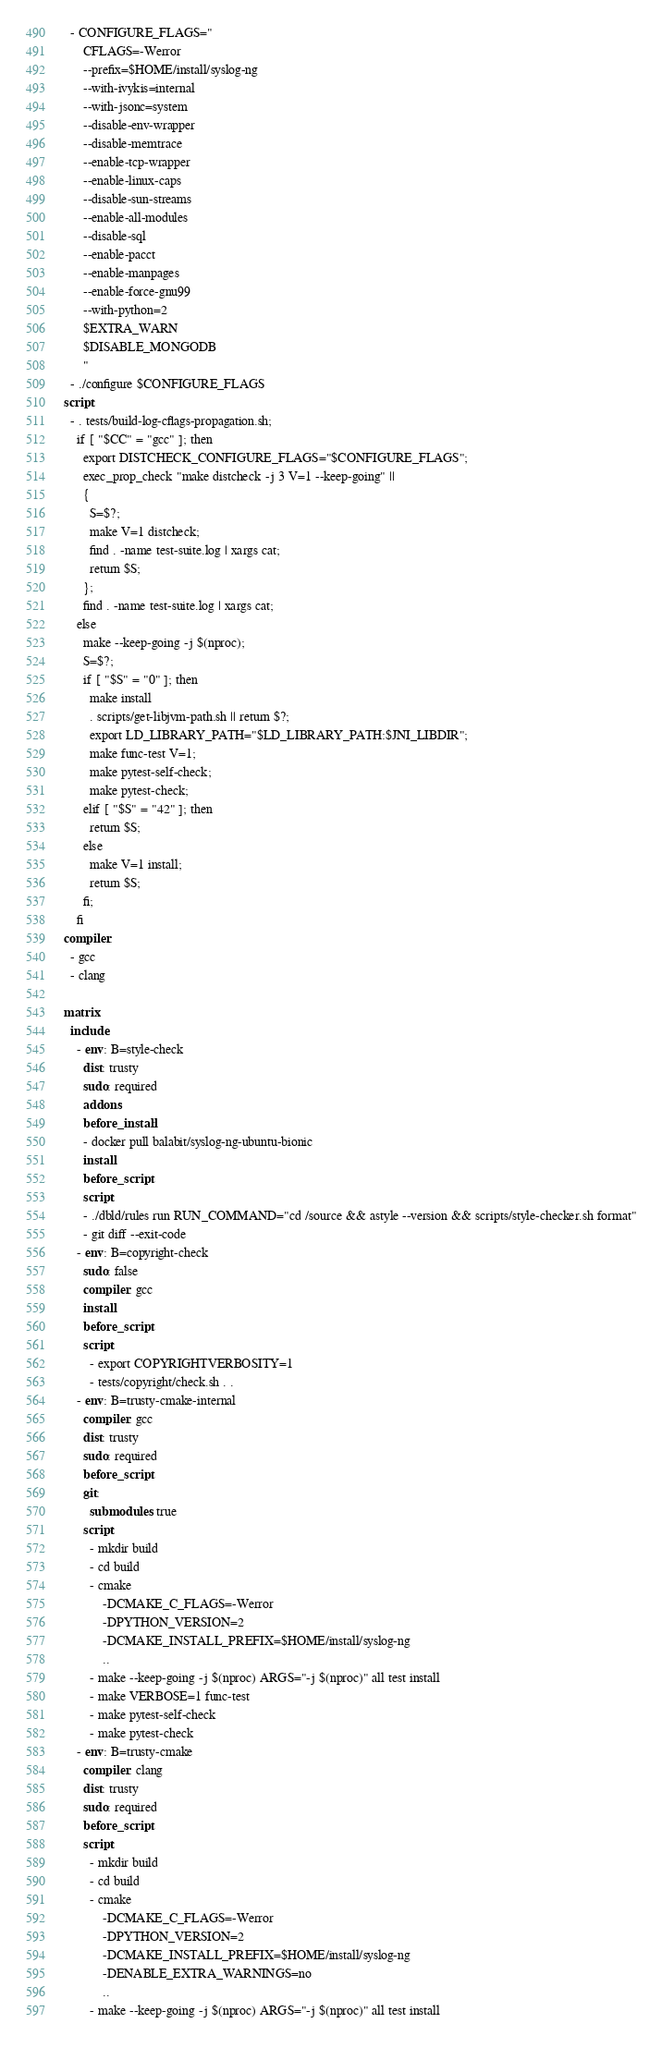<code> <loc_0><loc_0><loc_500><loc_500><_YAML_>  - CONFIGURE_FLAGS="
      CFLAGS=-Werror
      --prefix=$HOME/install/syslog-ng
      --with-ivykis=internal
      --with-jsonc=system
      --disable-env-wrapper
      --disable-memtrace
      --enable-tcp-wrapper
      --enable-linux-caps
      --disable-sun-streams
      --enable-all-modules
      --disable-sql
      --enable-pacct
      --enable-manpages
      --enable-force-gnu99
      --with-python=2
      $EXTRA_WARN
      $DISABLE_MONGODB
      "
  - ./configure $CONFIGURE_FLAGS
script:
  - . tests/build-log-cflags-propagation.sh;
    if [ "$CC" = "gcc" ]; then
      export DISTCHECK_CONFIGURE_FLAGS="$CONFIGURE_FLAGS";
      exec_prop_check "make distcheck -j 3 V=1 --keep-going" ||
      {
        S=$?;
        make V=1 distcheck;
        find . -name test-suite.log | xargs cat;
        return $S;
      };
      find . -name test-suite.log | xargs cat;
    else
      make --keep-going -j $(nproc);
      S=$?;
      if [ "$S" = "0" ]; then
        make install
        . scripts/get-libjvm-path.sh || return $?;
        export LD_LIBRARY_PATH="$LD_LIBRARY_PATH:$JNI_LIBDIR";
        make func-test V=1;
        make pytest-self-check;
        make pytest-check;
      elif [ "$S" = "42" ]; then
        return $S;
      else
        make V=1 install;
        return $S;
      fi;
    fi
compiler:
  - gcc
  - clang

matrix:
  include:
    - env: B=style-check
      dist: trusty
      sudo: required
      addons:
      before_install:
      - docker pull balabit/syslog-ng-ubuntu-bionic
      install:
      before_script:
      script:
      - ./dbld/rules run RUN_COMMAND="cd /source && astyle --version && scripts/style-checker.sh format"
      - git diff --exit-code
    - env: B=copyright-check
      sudo: false
      compiler: gcc
      install:
      before_script:
      script:
        - export COPYRIGHTVERBOSITY=1
        - tests/copyright/check.sh . .
    - env: B=trusty-cmake-internal
      compiler: gcc
      dist: trusty
      sudo: required
      before_script:
      git:
        submodules: true
      script:
        - mkdir build
        - cd build
        - cmake
            -DCMAKE_C_FLAGS=-Werror
            -DPYTHON_VERSION=2
            -DCMAKE_INSTALL_PREFIX=$HOME/install/syslog-ng
            ..
        - make --keep-going -j $(nproc) ARGS="-j $(nproc)" all test install
        - make VERBOSE=1 func-test
        - make pytest-self-check
        - make pytest-check
    - env: B=trusty-cmake
      compiler: clang
      dist: trusty
      sudo: required
      before_script:
      script:
        - mkdir build
        - cd build
        - cmake
            -DCMAKE_C_FLAGS=-Werror
            -DPYTHON_VERSION=2
            -DCMAKE_INSTALL_PREFIX=$HOME/install/syslog-ng
            -DENABLE_EXTRA_WARNINGS=no
            ..
        - make --keep-going -j $(nproc) ARGS="-j $(nproc)" all test install</code> 